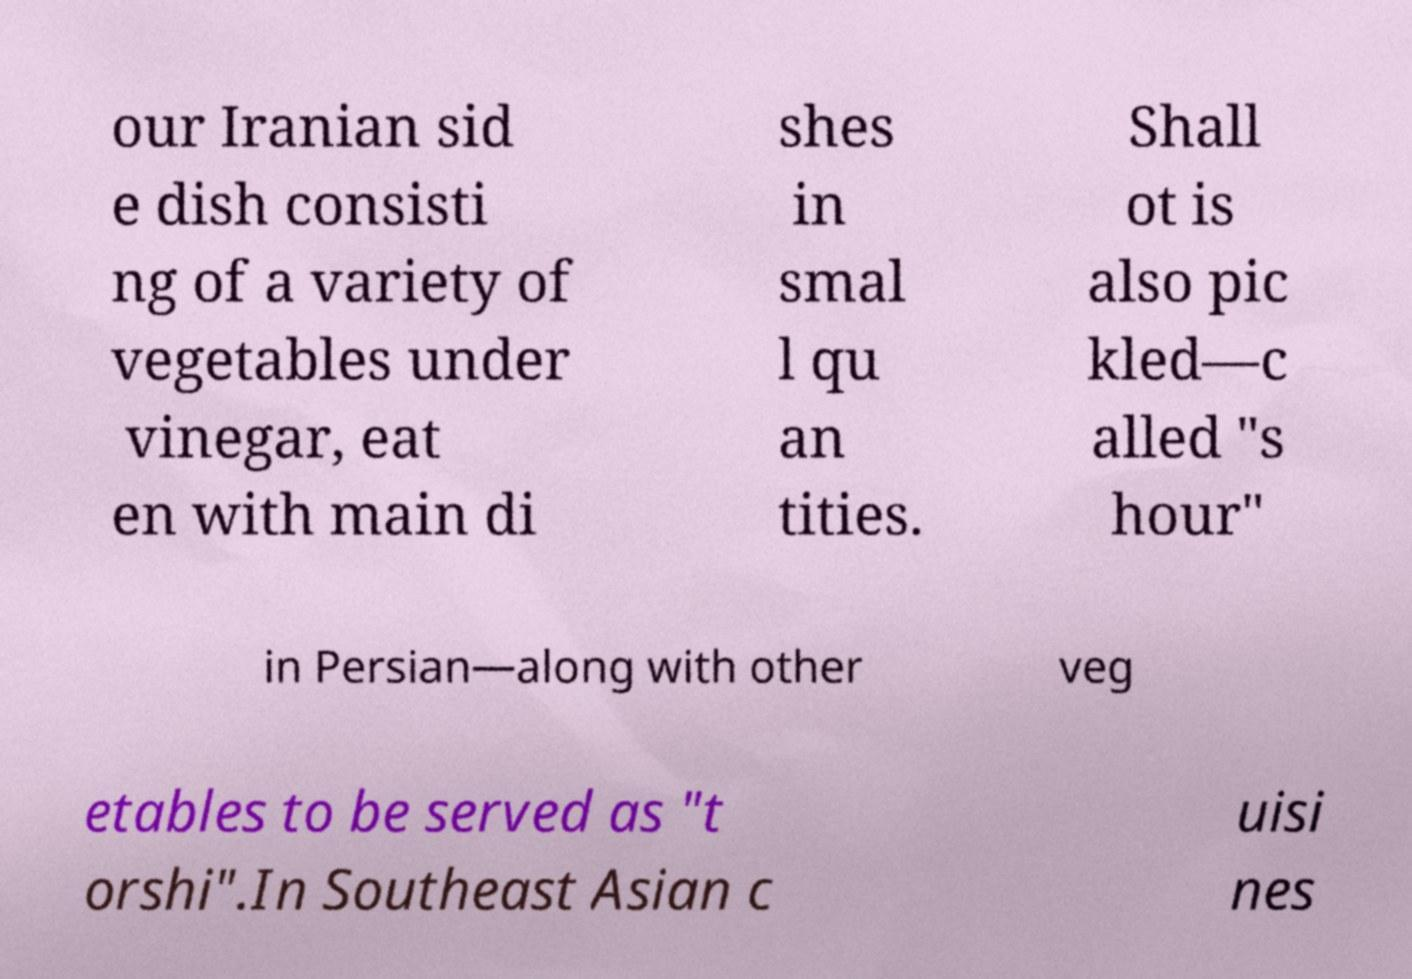Please identify and transcribe the text found in this image. our Iranian sid e dish consisti ng of a variety of vegetables under vinegar, eat en with main di shes in smal l qu an tities. Shall ot is also pic kled—c alled "s hour" in Persian—along with other veg etables to be served as "t orshi".In Southeast Asian c uisi nes 